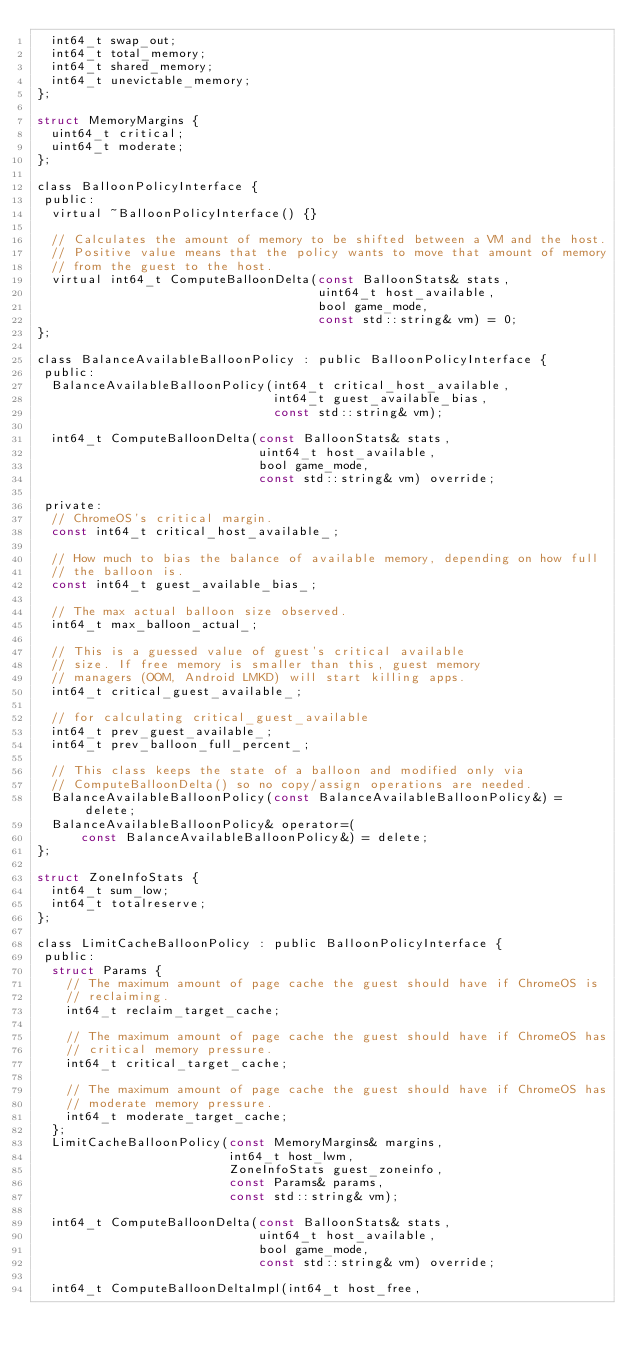<code> <loc_0><loc_0><loc_500><loc_500><_C_>  int64_t swap_out;
  int64_t total_memory;
  int64_t shared_memory;
  int64_t unevictable_memory;
};

struct MemoryMargins {
  uint64_t critical;
  uint64_t moderate;
};

class BalloonPolicyInterface {
 public:
  virtual ~BalloonPolicyInterface() {}

  // Calculates the amount of memory to be shifted between a VM and the host.
  // Positive value means that the policy wants to move that amount of memory
  // from the guest to the host.
  virtual int64_t ComputeBalloonDelta(const BalloonStats& stats,
                                      uint64_t host_available,
                                      bool game_mode,
                                      const std::string& vm) = 0;
};

class BalanceAvailableBalloonPolicy : public BalloonPolicyInterface {
 public:
  BalanceAvailableBalloonPolicy(int64_t critical_host_available,
                                int64_t guest_available_bias,
                                const std::string& vm);

  int64_t ComputeBalloonDelta(const BalloonStats& stats,
                              uint64_t host_available,
                              bool game_mode,
                              const std::string& vm) override;

 private:
  // ChromeOS's critical margin.
  const int64_t critical_host_available_;

  // How much to bias the balance of available memory, depending on how full
  // the balloon is.
  const int64_t guest_available_bias_;

  // The max actual balloon size observed.
  int64_t max_balloon_actual_;

  // This is a guessed value of guest's critical available
  // size. If free memory is smaller than this, guest memory
  // managers (OOM, Android LMKD) will start killing apps.
  int64_t critical_guest_available_;

  // for calculating critical_guest_available
  int64_t prev_guest_available_;
  int64_t prev_balloon_full_percent_;

  // This class keeps the state of a balloon and modified only via
  // ComputeBalloonDelta() so no copy/assign operations are needed.
  BalanceAvailableBalloonPolicy(const BalanceAvailableBalloonPolicy&) = delete;
  BalanceAvailableBalloonPolicy& operator=(
      const BalanceAvailableBalloonPolicy&) = delete;
};

struct ZoneInfoStats {
  int64_t sum_low;
  int64_t totalreserve;
};

class LimitCacheBalloonPolicy : public BalloonPolicyInterface {
 public:
  struct Params {
    // The maximum amount of page cache the guest should have if ChromeOS is
    // reclaiming.
    int64_t reclaim_target_cache;

    // The maximum amount of page cache the guest should have if ChromeOS has
    // critical memory pressure.
    int64_t critical_target_cache;

    // The maximum amount of page cache the guest should have if ChromeOS has
    // moderate memory pressure.
    int64_t moderate_target_cache;
  };
  LimitCacheBalloonPolicy(const MemoryMargins& margins,
                          int64_t host_lwm,
                          ZoneInfoStats guest_zoneinfo,
                          const Params& params,
                          const std::string& vm);

  int64_t ComputeBalloonDelta(const BalloonStats& stats,
                              uint64_t host_available,
                              bool game_mode,
                              const std::string& vm) override;

  int64_t ComputeBalloonDeltaImpl(int64_t host_free,</code> 